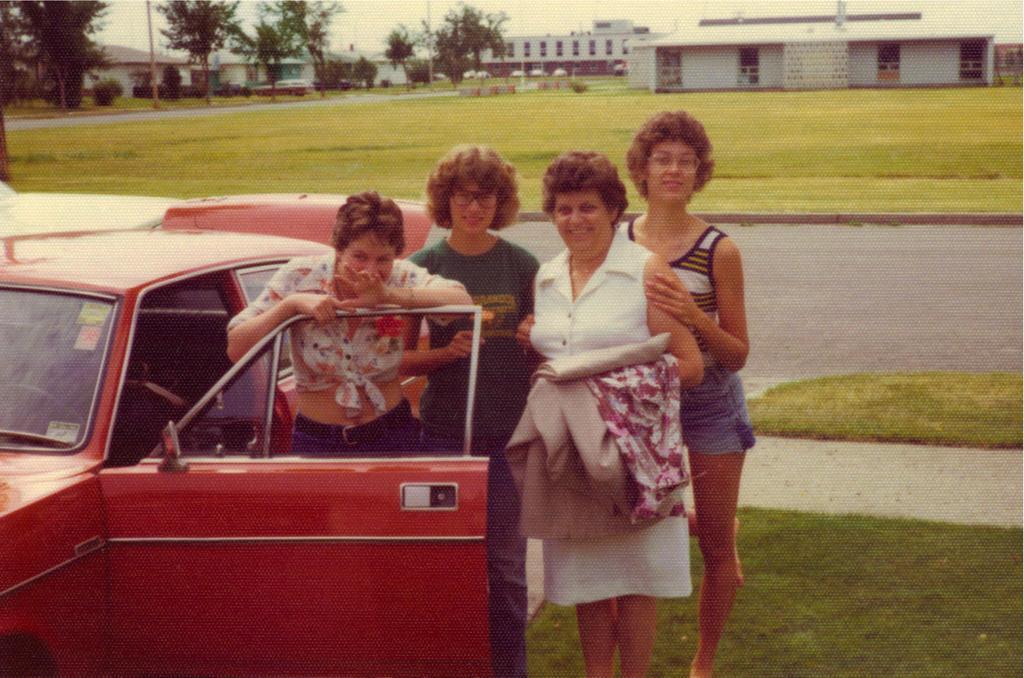Can you describe this image briefly? In this picture I can see buildings, trees and few women standing and I can see a red color car and grass on the ground. 